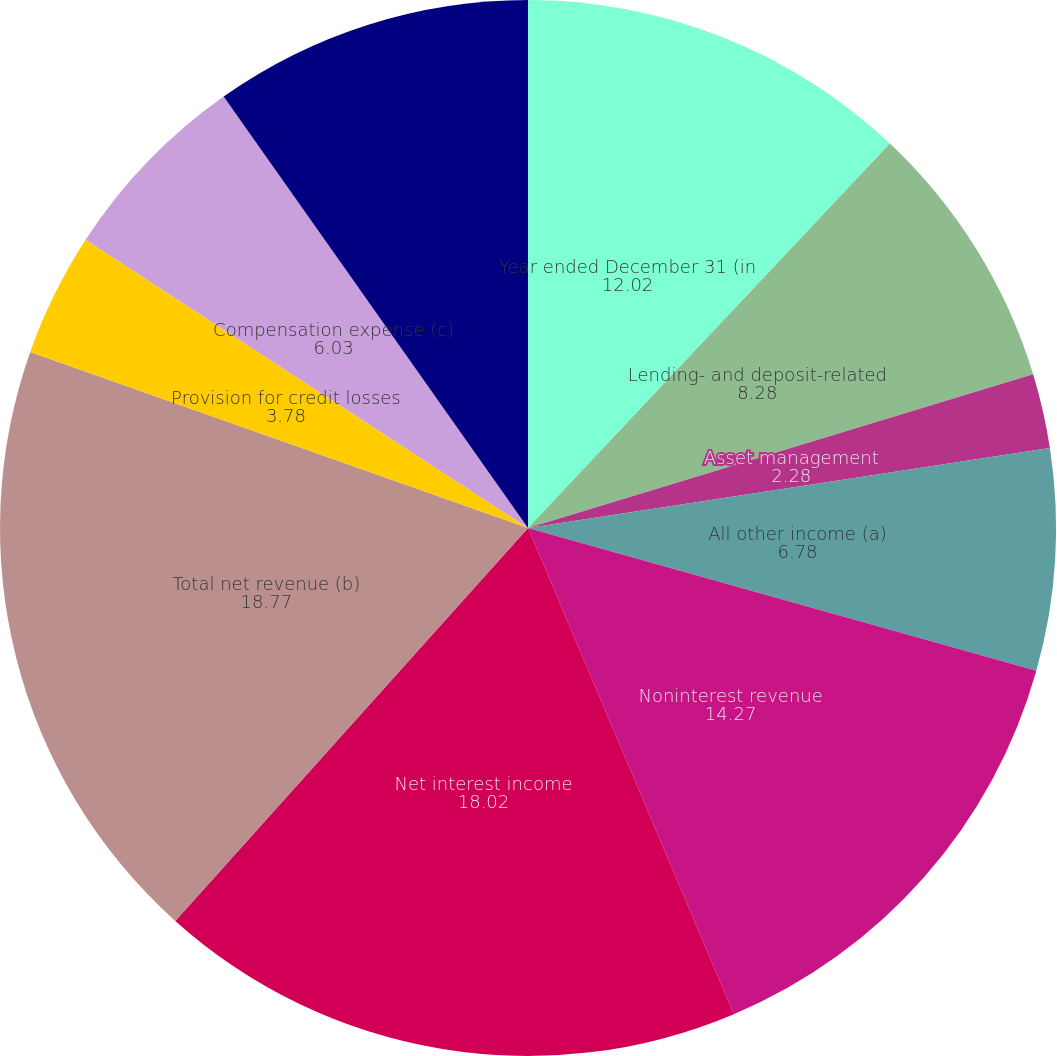Convert chart to OTSL. <chart><loc_0><loc_0><loc_500><loc_500><pie_chart><fcel>Year ended December 31 (in<fcel>Lending- and deposit-related<fcel>Asset management<fcel>All other income (a)<fcel>Noninterest revenue<fcel>Net interest income<fcel>Total net revenue (b)<fcel>Provision for credit losses<fcel>Compensation expense (c)<fcel>Noncompensation expense (c)<nl><fcel>12.02%<fcel>8.28%<fcel>2.28%<fcel>6.78%<fcel>14.27%<fcel>18.02%<fcel>18.77%<fcel>3.78%<fcel>6.03%<fcel>9.78%<nl></chart> 